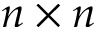Convert formula to latex. <formula><loc_0><loc_0><loc_500><loc_500>n \times n</formula> 